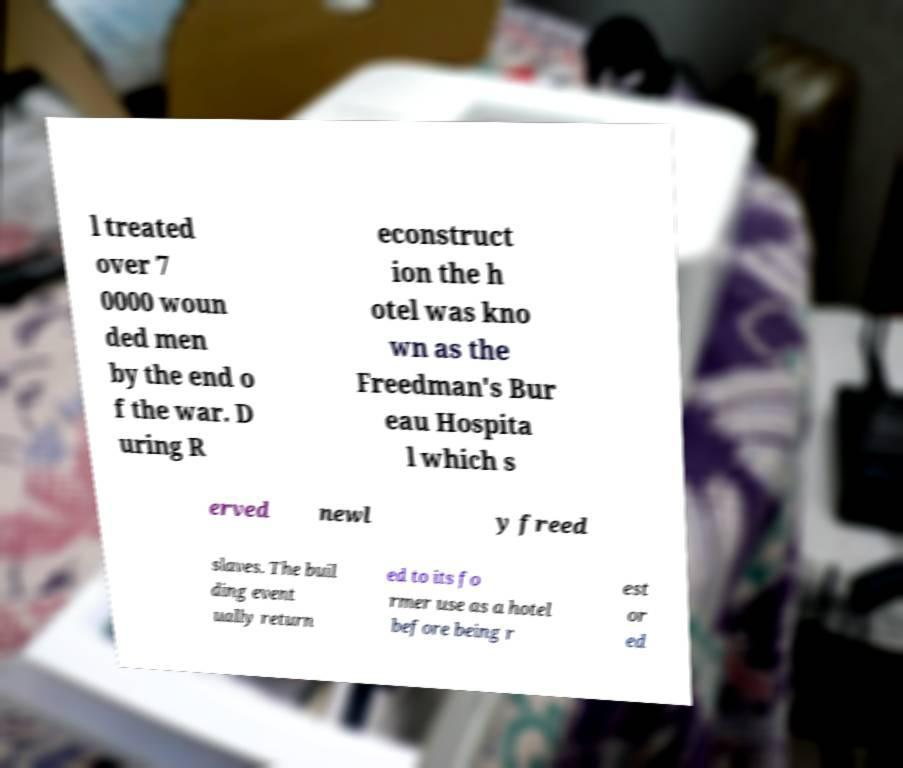Can you read and provide the text displayed in the image?This photo seems to have some interesting text. Can you extract and type it out for me? l treated over 7 0000 woun ded men by the end o f the war. D uring R econstruct ion the h otel was kno wn as the Freedman's Bur eau Hospita l which s erved newl y freed slaves. The buil ding event ually return ed to its fo rmer use as a hotel before being r est or ed 